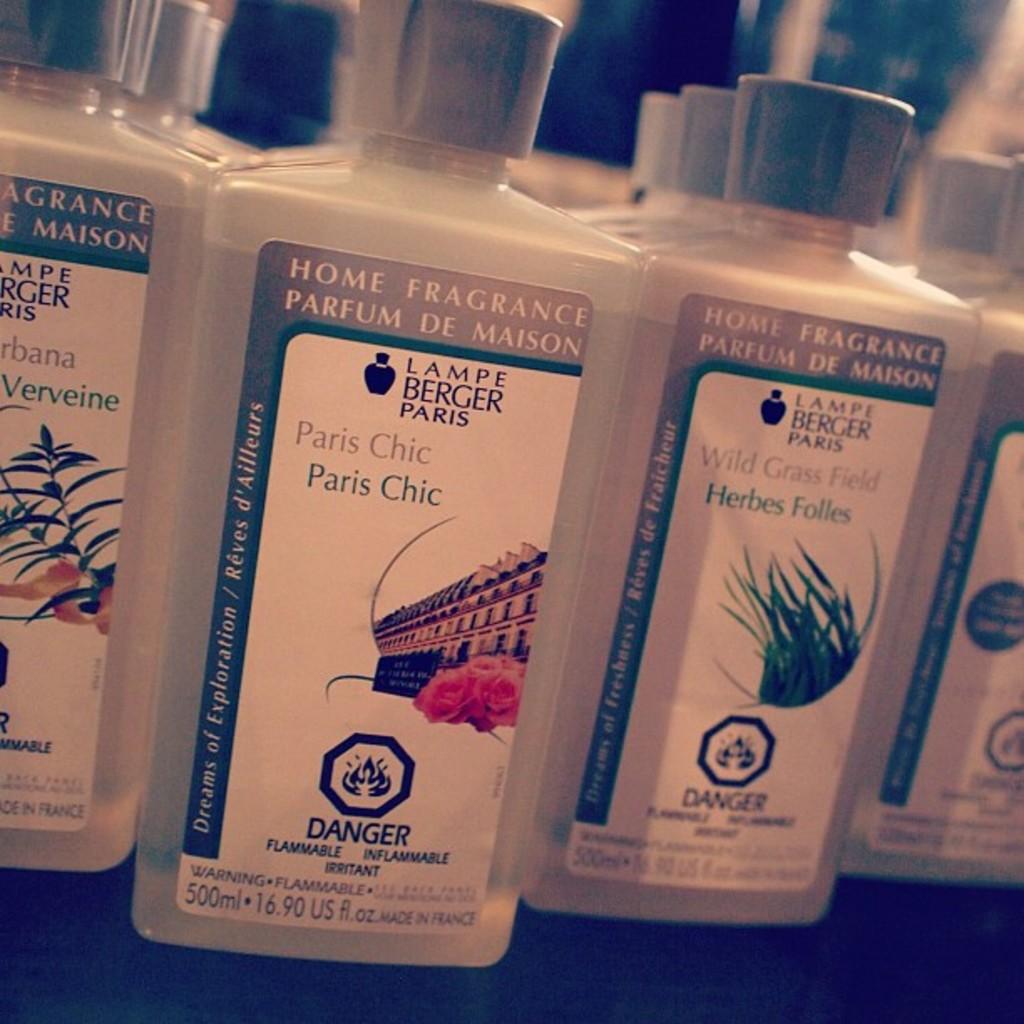What does the danger warning warn of?
Offer a very short reply. Flammable. What is this fragrance for?
Your response must be concise. Home fragrance. 